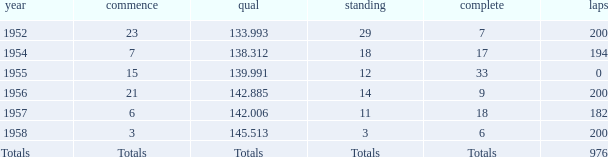What place did Jimmy Reece finish in 1957? 18.0. 